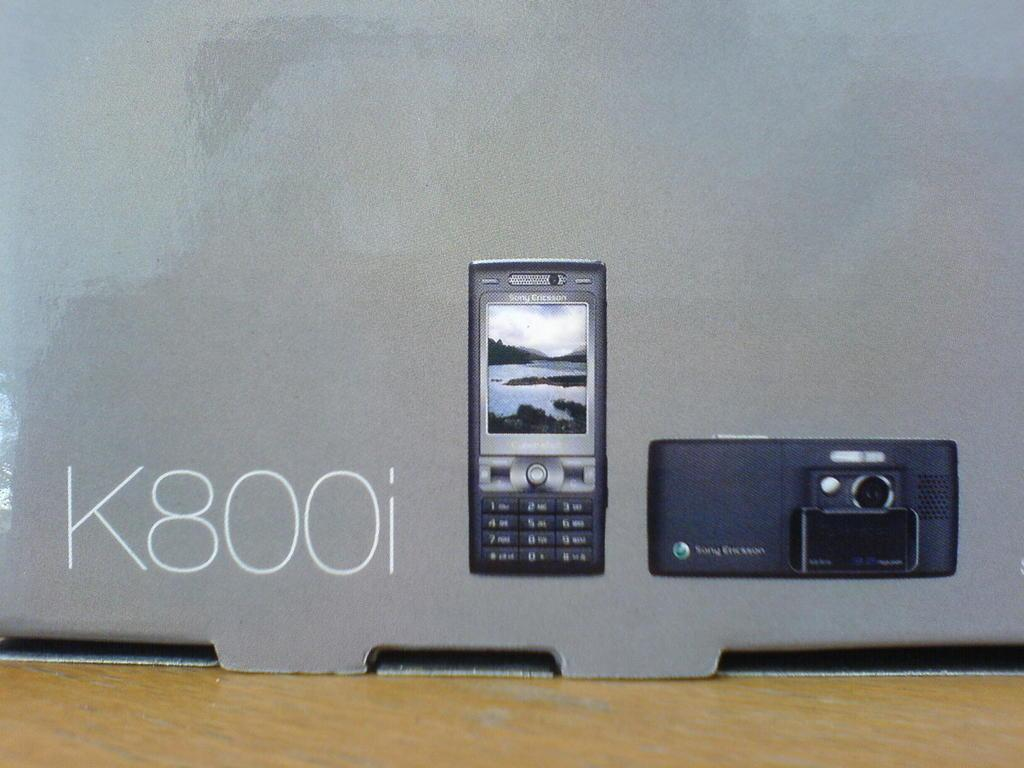<image>
Render a clear and concise summary of the photo. A couple of Sony Ericcson devices in a box that ssya K 800I. 